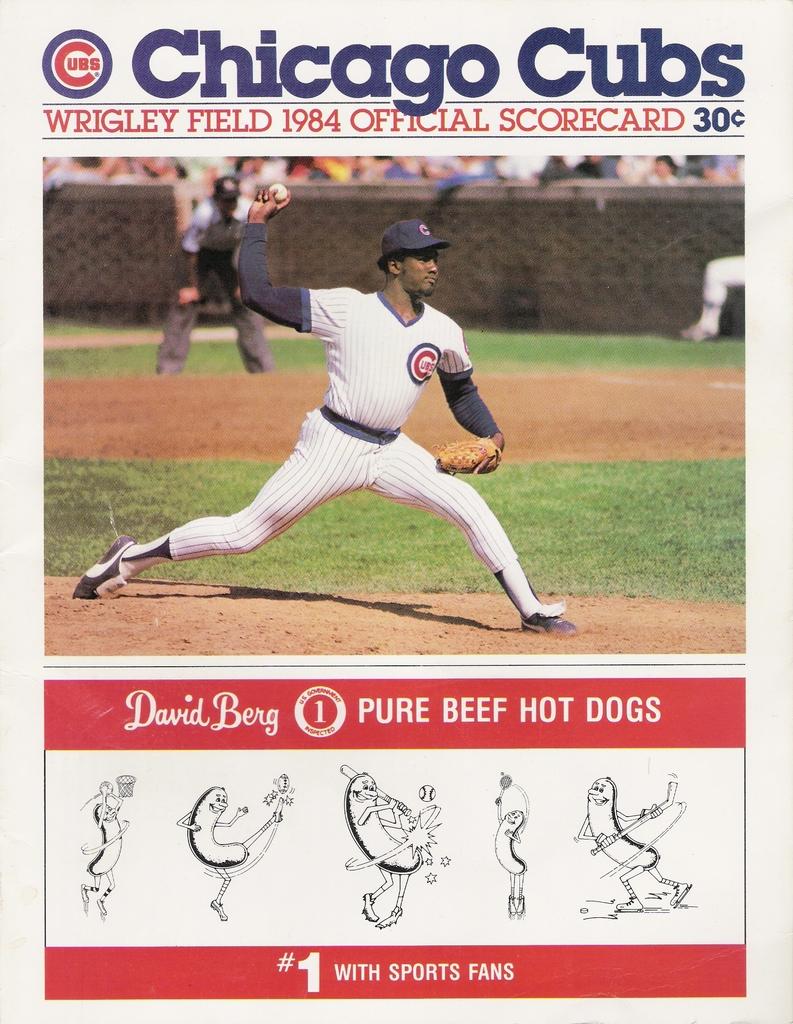Who is playing in the game?
Keep it short and to the point. Chicago cubs. What type of meat are the hot dogs?
Your answer should be compact. Beef. 